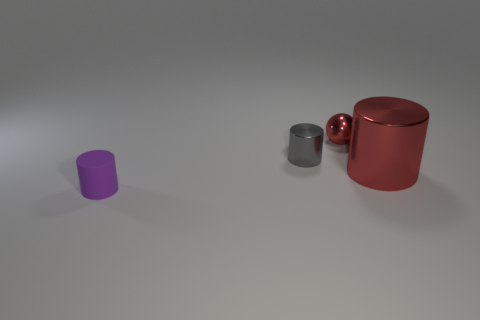Add 1 tiny brown metallic cylinders. How many objects exist? 5 Subtract all spheres. How many objects are left? 3 Subtract 0 cyan cylinders. How many objects are left? 4 Subtract all red cylinders. Subtract all tiny purple things. How many objects are left? 2 Add 3 tiny gray metallic objects. How many tiny gray metallic objects are left? 4 Add 1 tiny shiny balls. How many tiny shiny balls exist? 2 